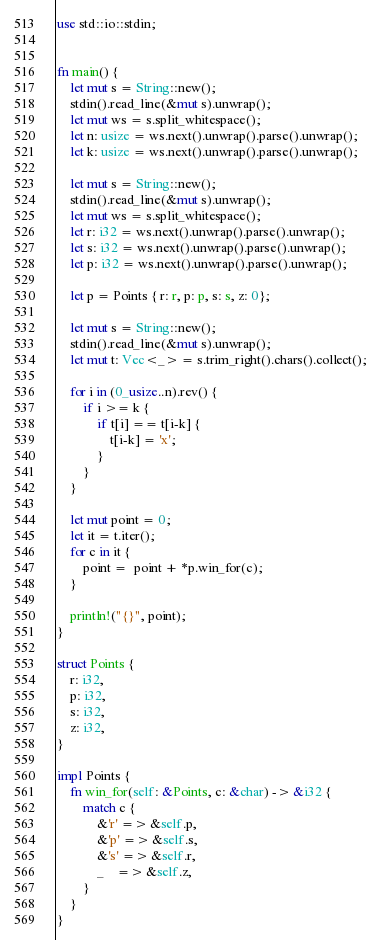<code> <loc_0><loc_0><loc_500><loc_500><_Rust_>use std::io::stdin;


fn main() {
    let mut s = String::new();
    stdin().read_line(&mut s).unwrap();
    let mut ws = s.split_whitespace();
    let n: usize = ws.next().unwrap().parse().unwrap();
    let k: usize = ws.next().unwrap().parse().unwrap();

    let mut s = String::new();
    stdin().read_line(&mut s).unwrap();
    let mut ws = s.split_whitespace();
    let r: i32 = ws.next().unwrap().parse().unwrap();
    let s: i32 = ws.next().unwrap().parse().unwrap();
    let p: i32 = ws.next().unwrap().parse().unwrap();

    let p = Points { r: r, p: p, s: s, z: 0};

    let mut s = String::new();
    stdin().read_line(&mut s).unwrap();
    let mut t: Vec<_> = s.trim_right().chars().collect();

    for i in (0_usize..n).rev() {
        if i >= k {
            if t[i] == t[i-k] {
                t[i-k] = 'x';
            }
        }
    }

    let mut point = 0;
    let it = t.iter();
    for c in it {
        point =  point + *p.win_for(c);
    }

    println!("{}", point);
}

struct Points {
    r: i32,
    p: i32,
    s: i32,
    z: i32,
}

impl Points {
    fn win_for(self: &Points, c: &char) -> &i32 {
        match c {
            &'r' => &self.p,
            &'p' => &self.s,
            &'s' => &self.r,
            _    => &self.z,
        }
    }
}
</code> 